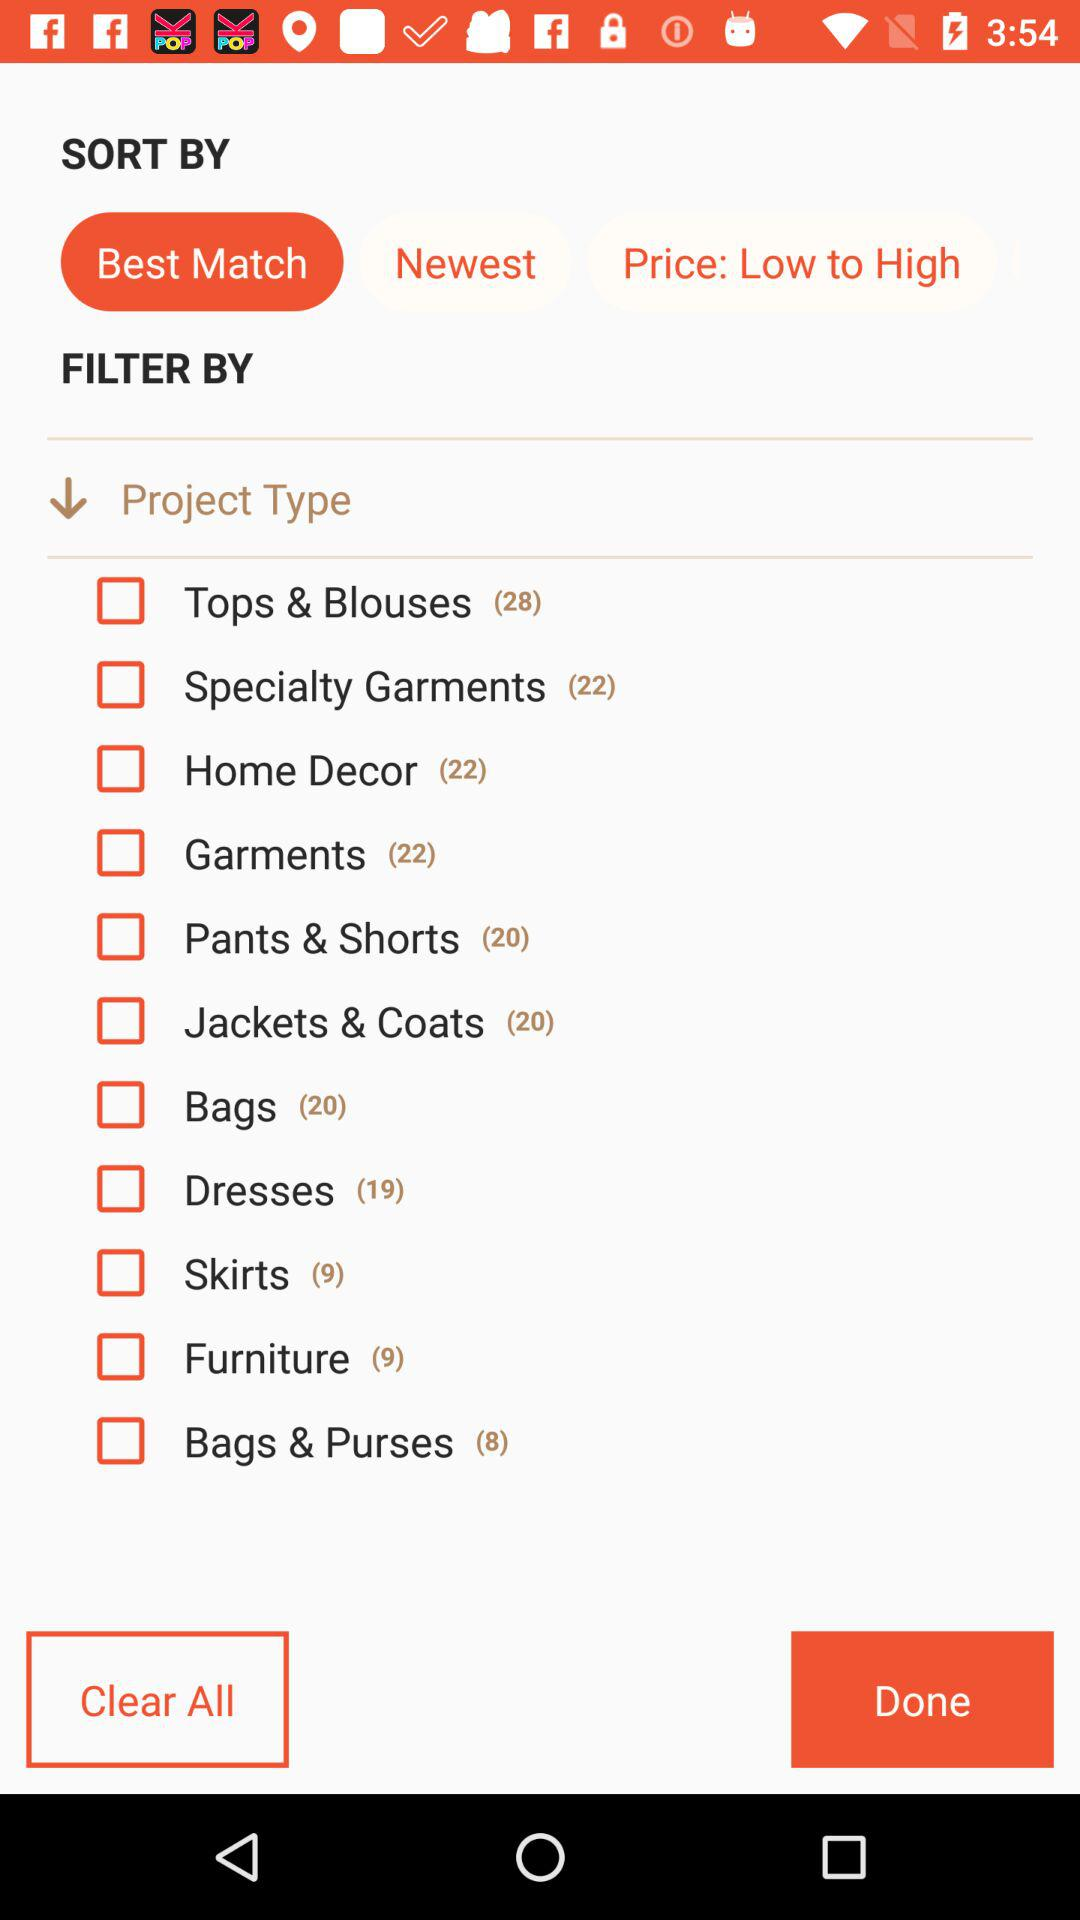How many varieties of bags are there? There are 20 varieties of bags. 